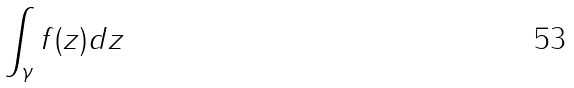Convert formula to latex. <formula><loc_0><loc_0><loc_500><loc_500>\int _ { \gamma } f ( z ) d z</formula> 